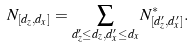Convert formula to latex. <formula><loc_0><loc_0><loc_500><loc_500>N _ { [ d _ { z } , d _ { x } ] } = \sum _ { d _ { z } ^ { \prime } \leq d _ { z } , d _ { x } ^ { \prime } \leq d _ { x } } N _ { [ d _ { z } ^ { \prime } , d _ { x } ^ { \prime } ] } ^ { \ast } .</formula> 